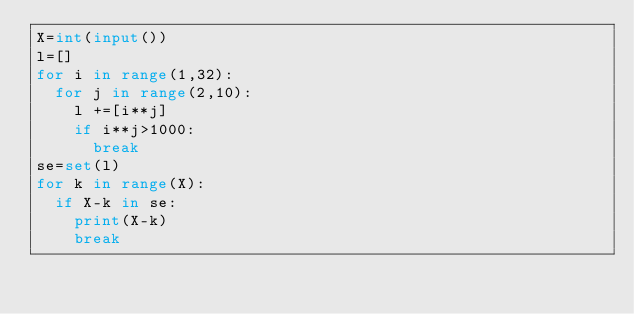Convert code to text. <code><loc_0><loc_0><loc_500><loc_500><_Python_>X=int(input())
l=[]
for i in range(1,32):
  for j in range(2,10):
    l +=[i**j]
    if i**j>1000:
      break
se=set(l)
for k in range(X):
  if X-k in se:
    print(X-k)
    break</code> 